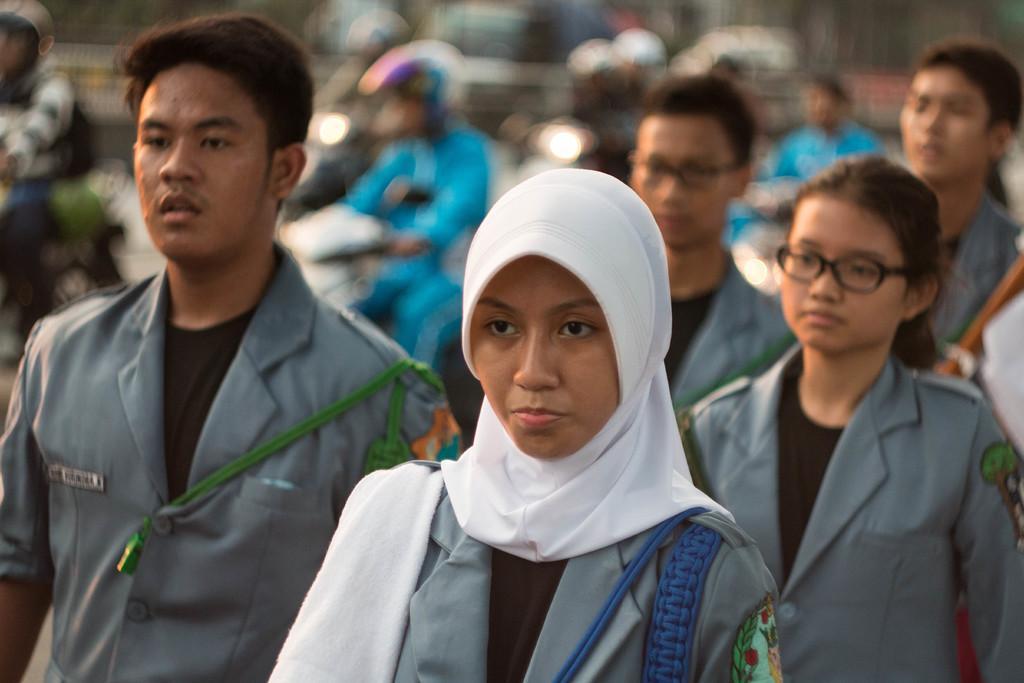Could you give a brief overview of what you see in this image? In this image there are a few people standing, behind them there are few people riding on their bikes, which is blurred. 